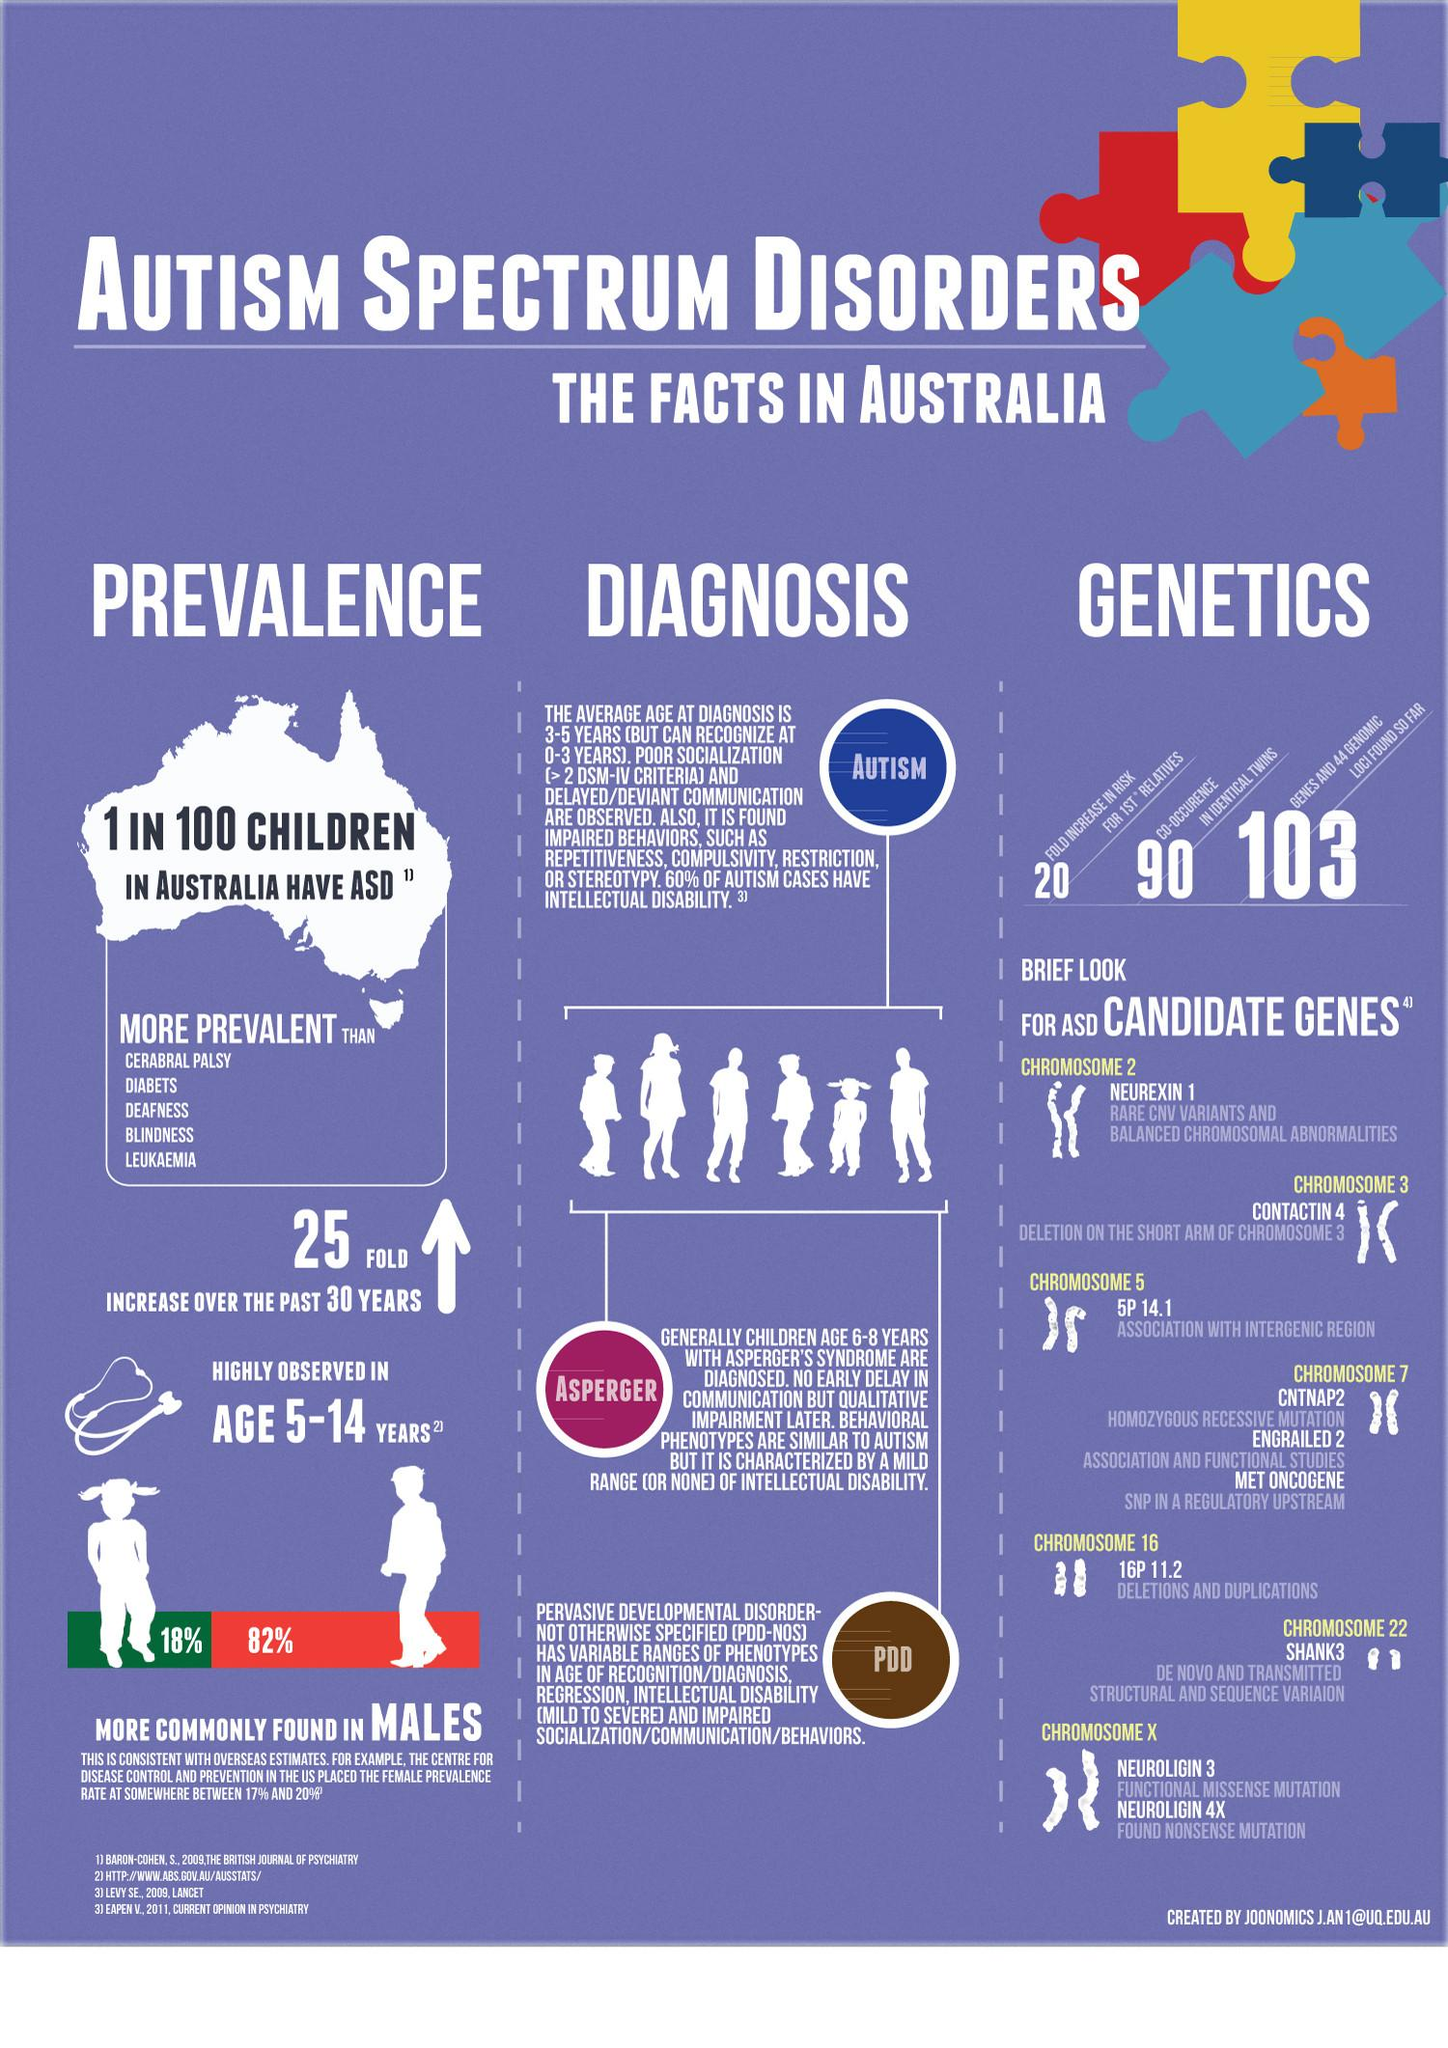Mention a couple of crucial points in this snapshot. In Australia, it is estimated that approximately 18% of females aged 5-14 years have autism. A recent study in Australia has revealed that 82% of males aged 5-14 years have autism. 